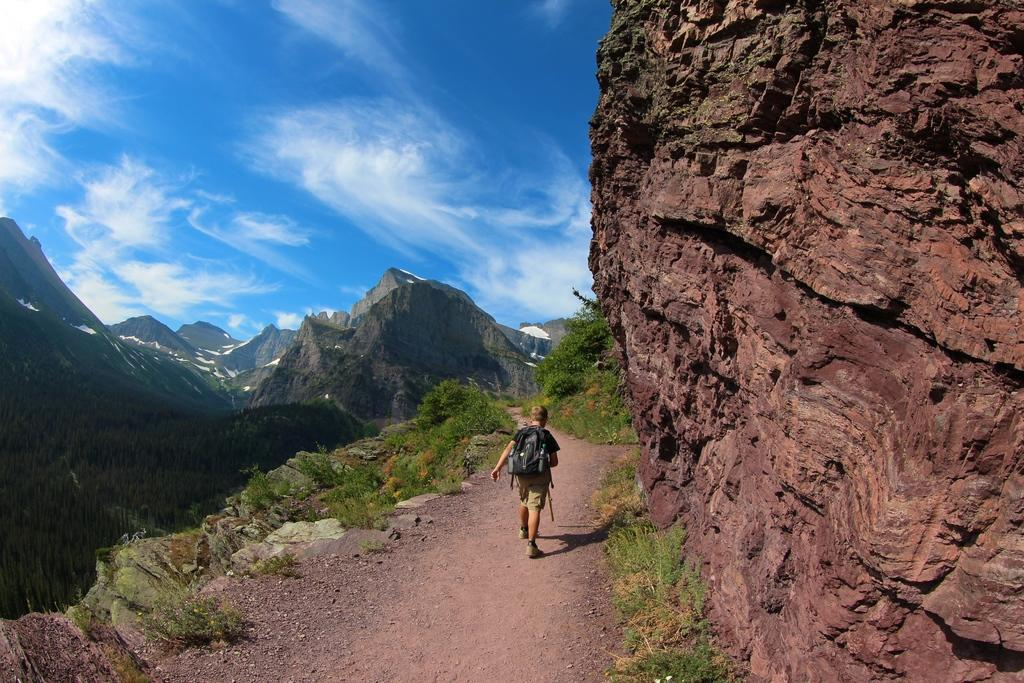What is the person in the image doing? The person is walking in the image. Where is the person walking? The person is walking on a pathway. What natural features can be seen in the background of the image? Mountains, trees, and bushes are visible in the image. What is the condition of the sky in the image? There are clouds in the sky. Where is the judge sitting in the image? There is no judge present in the image; it features a person walking on a pathway with natural features in the background. 